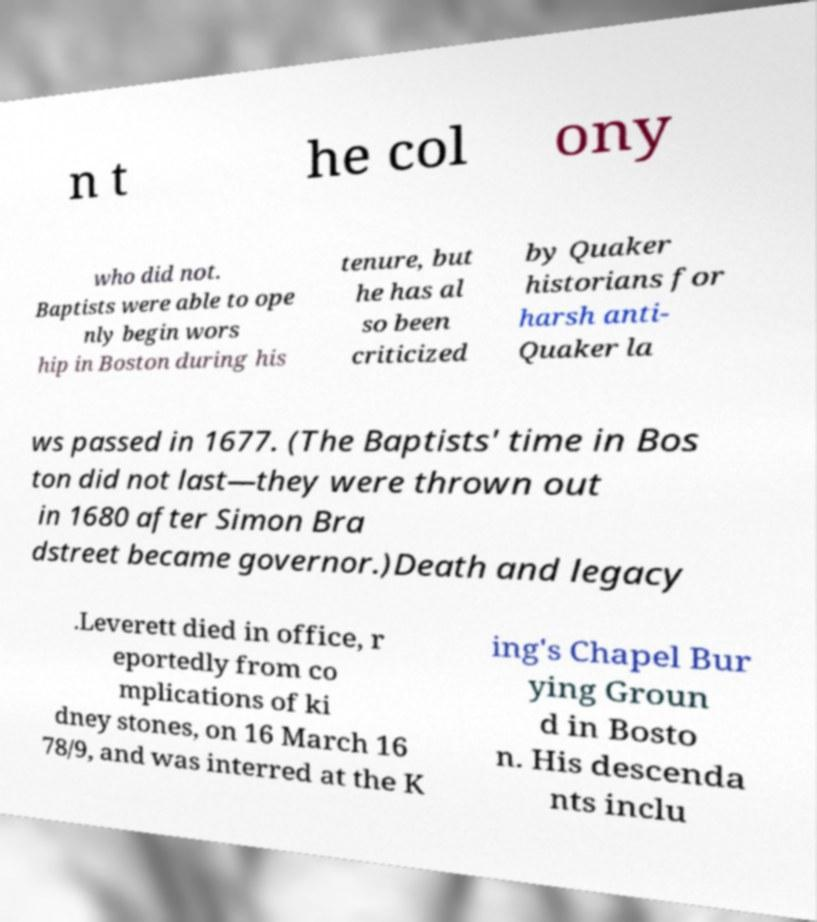Could you assist in decoding the text presented in this image and type it out clearly? n t he col ony who did not. Baptists were able to ope nly begin wors hip in Boston during his tenure, but he has al so been criticized by Quaker historians for harsh anti- Quaker la ws passed in 1677. (The Baptists' time in Bos ton did not last—they were thrown out in 1680 after Simon Bra dstreet became governor.)Death and legacy .Leverett died in office, r eportedly from co mplications of ki dney stones, on 16 March 16 78/9, and was interred at the K ing's Chapel Bur ying Groun d in Bosto n. His descenda nts inclu 